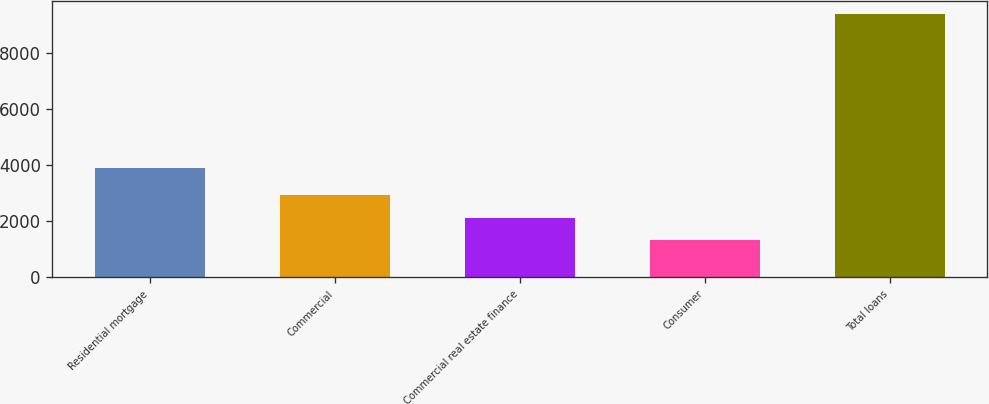<chart> <loc_0><loc_0><loc_500><loc_500><bar_chart><fcel>Residential mortgage<fcel>Commercial<fcel>Commercial real estate finance<fcel>Consumer<fcel>Total loans<nl><fcel>3900.1<fcel>2931.38<fcel>2126.34<fcel>1321.3<fcel>9371.7<nl></chart> 